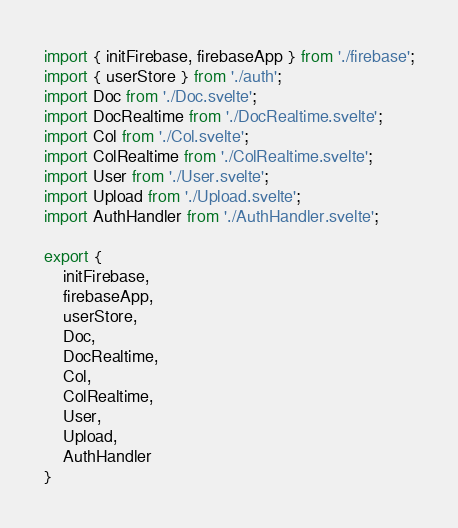Convert code to text. <code><loc_0><loc_0><loc_500><loc_500><_TypeScript_>import { initFirebase, firebaseApp } from './firebase';
import { userStore } from './auth';
import Doc from './Doc.svelte';
import DocRealtime from './DocRealtime.svelte';
import Col from './Col.svelte';
import ColRealtime from './ColRealtime.svelte';
import User from './User.svelte';
import Upload from './Upload.svelte';
import AuthHandler from './AuthHandler.svelte';

export {
    initFirebase,
    firebaseApp,
    userStore,
    Doc,
    DocRealtime,
    Col,
    ColRealtime,
    User,
    Upload,
    AuthHandler
}

</code> 